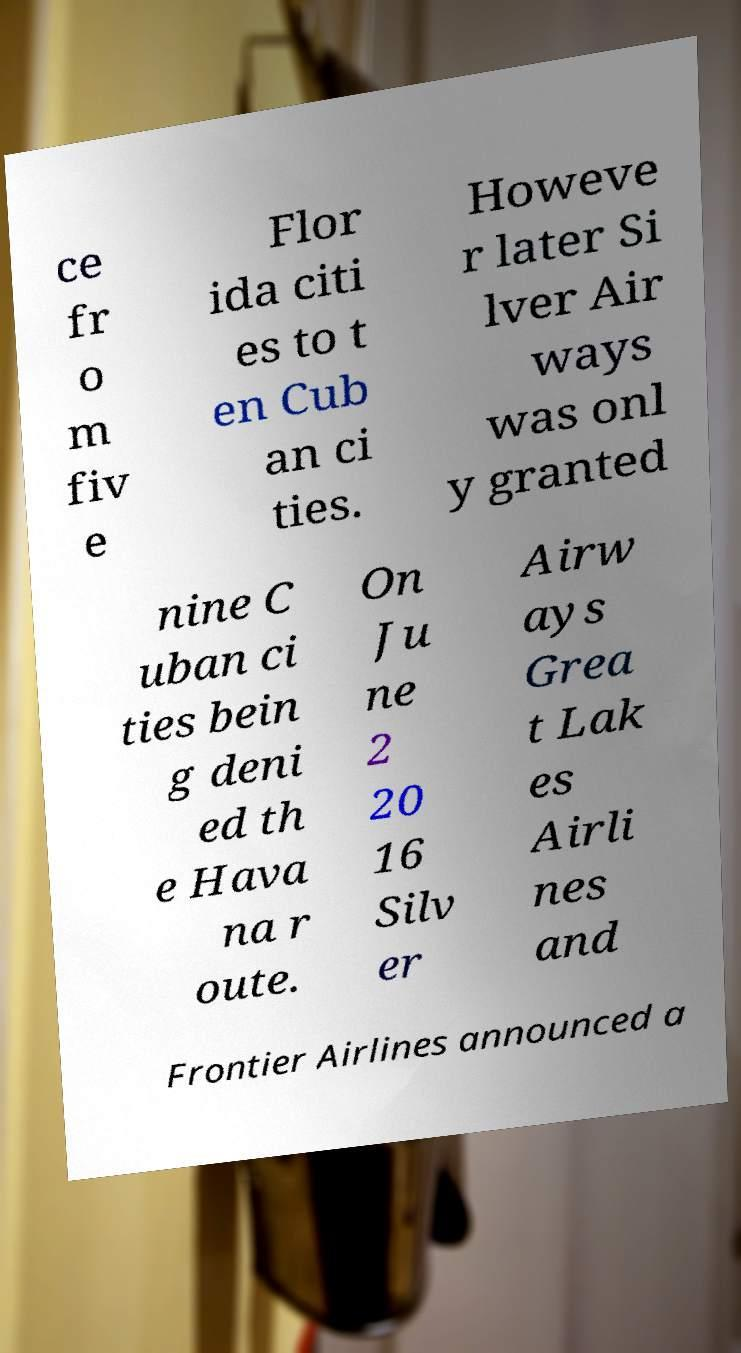Can you accurately transcribe the text from the provided image for me? ce fr o m fiv e Flor ida citi es to t en Cub an ci ties. Howeve r later Si lver Air ways was onl y granted nine C uban ci ties bein g deni ed th e Hava na r oute. On Ju ne 2 20 16 Silv er Airw ays Grea t Lak es Airli nes and Frontier Airlines announced a 